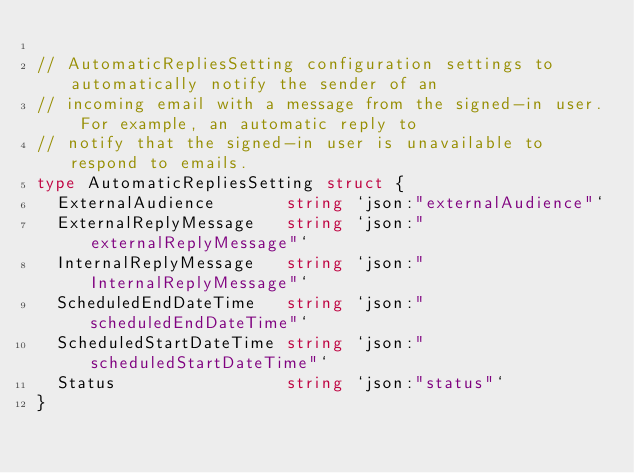Convert code to text. <code><loc_0><loc_0><loc_500><loc_500><_Go_>
// AutomaticRepliesSetting configuration settings to automatically notify the sender of an
// incoming email with a message from the signed-in user. For example, an automatic reply to
// notify that the signed-in user is unavailable to respond to emails.
type AutomaticRepliesSetting struct {
	ExternalAudience       string `json:"externalAudience"`
	ExternalReplyMessage   string `json:"externalReplyMessage"`
	InternalReplyMessage   string `json:"InternalReplyMessage"`
	ScheduledEndDateTime   string `json:"scheduledEndDateTime"`
	ScheduledStartDateTime string `json:"scheduledStartDateTime"`
	Status                 string `json:"status"`
}
</code> 